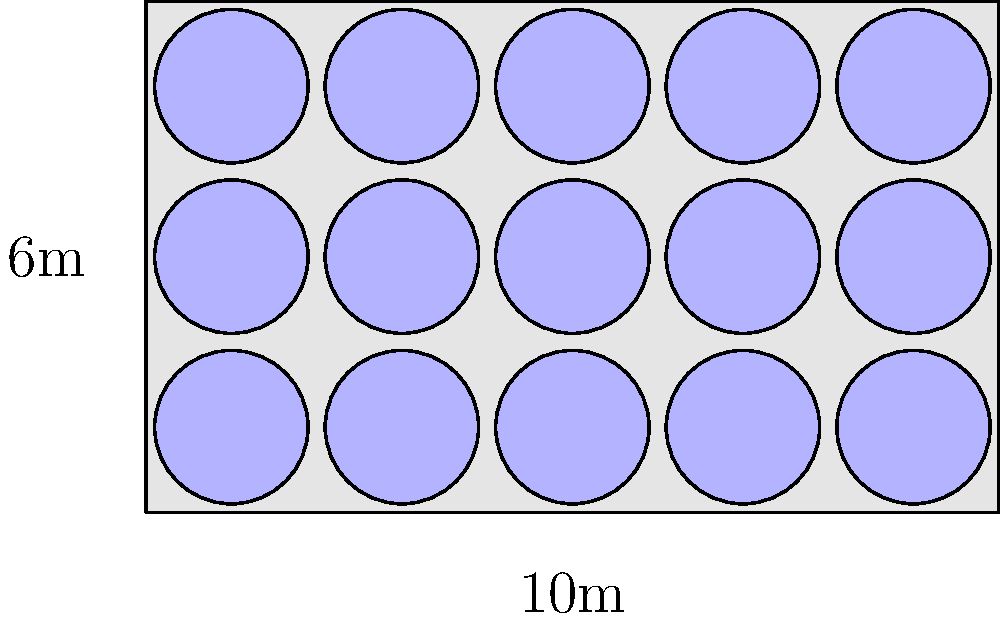As a fast-food worker, you're tasked with arranging circular tables in the rectangular dining area for a special breakfast event. The dining area is $10$ meters long and $6$ meters wide. If each circular table has a diameter of $1.8$ meters and needs $0.2$ meters of space around it for easy movement, what's the maximum number of tables that can fit in the dining area? Let's approach this step-by-step:

1) First, we need to calculate the effective space each table occupies:
   Diameter + Space around = $1.8\text{m} + (2 \times 0.2\text{m}) = 2.2\text{m}$

2) Now, let's see how many tables can fit along the length:
   $10\text{m} \div 2.2\text{m} \approx 4.54$
   We can fit 4 tables along the length.

3) For the width:
   $6\text{m} \div 2.2\text{m} \approx 2.72$
   We can fit 2 tables along the width.

4) The total number of tables is the product of tables along length and width:
   $4 \times 2 = 8$ tables

5) However, we can optimize further. There's some extra space:
   Length: $10\text{m} - (4 \times 2.2\text{m}) = 1.2\text{m}$
   Width: $6\text{m} - (2 \times 2.2\text{m}) = 1.6\text{m}$

6) We can fit one more table in the center of this extra space:
   $1.2\text{m} > 1.8\text{m}$ (table diameter)
   $1.6\text{m} > 1.8\text{m}$ (table diameter)

Therefore, we can fit a total of $8 + 1 = 9$ tables in the dining area.
Answer: 9 tables 